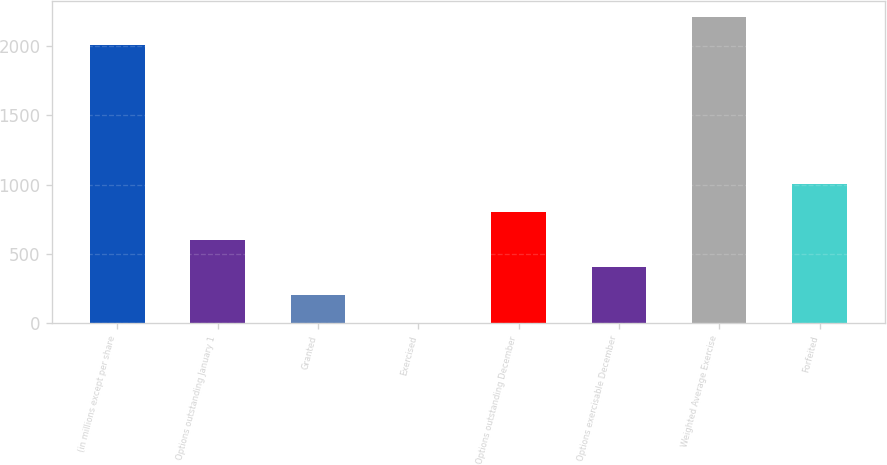Convert chart. <chart><loc_0><loc_0><loc_500><loc_500><bar_chart><fcel>(in millions except per share<fcel>Options outstanding January 1<fcel>Granted<fcel>Exercised<fcel>Options outstanding December<fcel>Options exercisable December<fcel>Weighted Average Exercise<fcel>Forfeited<nl><fcel>2011<fcel>603.58<fcel>201.46<fcel>0.4<fcel>804.64<fcel>402.52<fcel>2212.06<fcel>1005.7<nl></chart> 